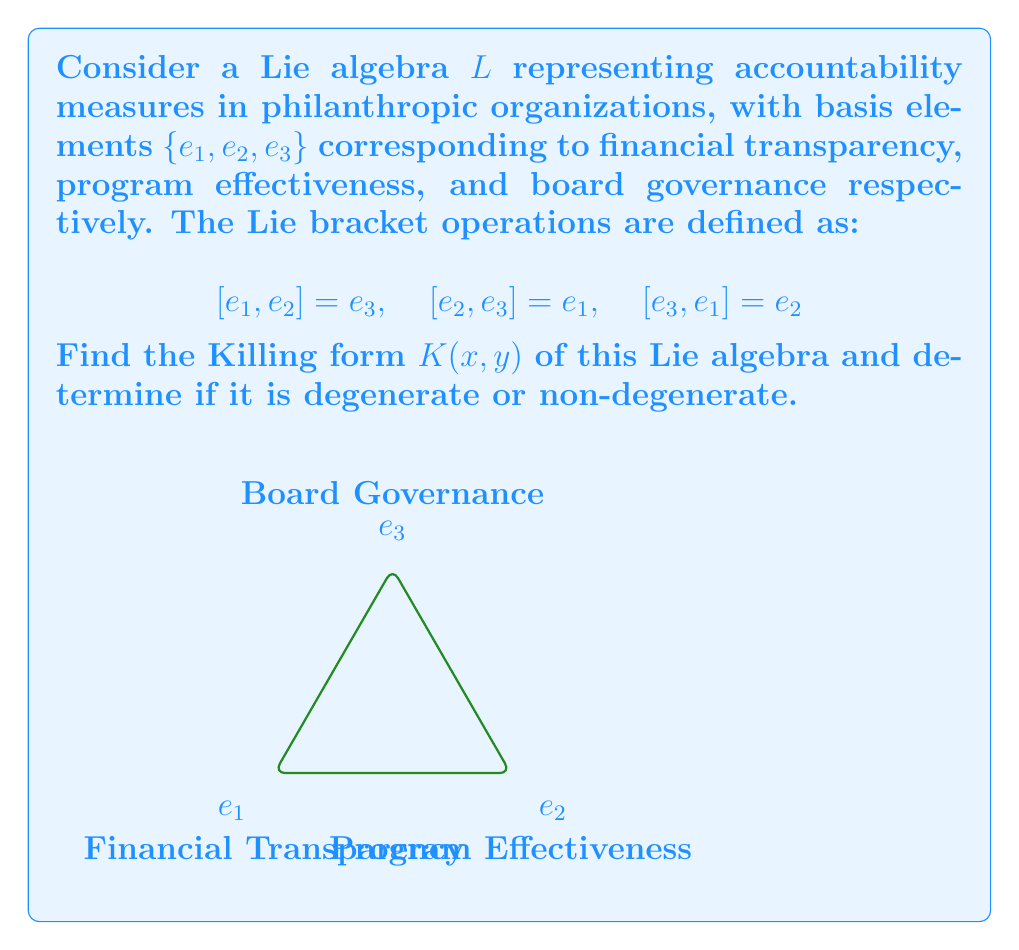Help me with this question. To find the Killing form of the Lie algebra $L$, we follow these steps:

1) The Killing form is defined as $K(x,y) = \text{tr}(\text{ad}_x \circ \text{ad}_y)$, where $\text{ad}_x$ is the adjoint representation of $x$.

2) First, we need to find the matrices of $\text{ad}_{e_1}$, $\text{ad}_{e_2}$, and $\text{ad}_{e_3}$:

   $\text{ad}_{e_1} = \begin{pmatrix} 0 & 0 & -1 \\ 0 & 0 & 0 \\ 0 & 1 & 0 \end{pmatrix}$

   $\text{ad}_{e_2} = \begin{pmatrix} 0 & 0 & 0 \\ -1 & 0 & 0 \\ 0 & 1 & 0 \end{pmatrix}$

   $\text{ad}_{e_3} = \begin{pmatrix} 0 & 1 & 0 \\ -1 & 0 & 0 \\ 0 & 0 & 0 \end{pmatrix}$

3) Now, we compute $K(e_i, e_j)$ for all $i,j \in \{1,2,3\}$:

   $K(e_1, e_1) = \text{tr}(\text{ad}_{e_1} \circ \text{ad}_{e_1}) = -2$
   $K(e_2, e_2) = \text{tr}(\text{ad}_{e_2} \circ \text{ad}_{e_2}) = -2$
   $K(e_3, e_3) = \text{tr}(\text{ad}_{e_3} \circ \text{ad}_{e_3}) = -2$
   $K(e_1, e_2) = K(e_2, e_1) = \text{tr}(\text{ad}_{e_1} \circ \text{ad}_{e_2}) = 0$
   $K(e_1, e_3) = K(e_3, e_1) = \text{tr}(\text{ad}_{e_1} \circ \text{ad}_{e_3}) = 0$
   $K(e_2, e_3) = K(e_3, e_2) = \text{tr}(\text{ad}_{e_2} \circ \text{ad}_{e_3}) = 0$

4) The Killing form matrix is:

   $K = \begin{pmatrix} -2 & 0 & 0 \\ 0 & -2 & 0 \\ 0 & 0 & -2 \end{pmatrix}$

5) To determine if the Killing form is degenerate or non-degenerate, we calculate its determinant:

   $\det(K) = (-2)^3 = -8 \neq 0$

Since the determinant is non-zero, the Killing form is non-degenerate.
Answer: $K(x,y) = -2(x_1y_1 + x_2y_2 + x_3y_3)$, non-degenerate 